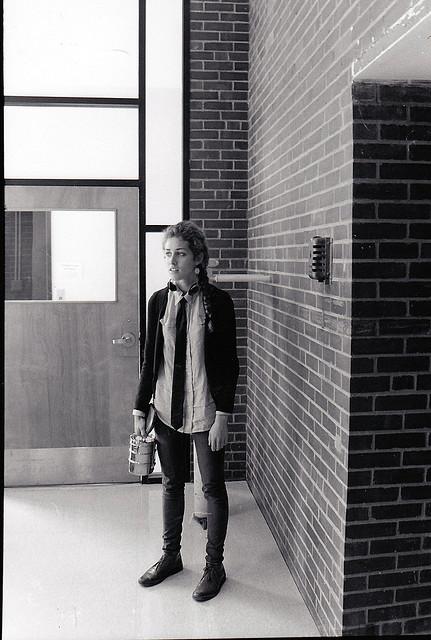What sort of boots are these?
Be succinct. Hiking. What is the wall made of?
Write a very short answer. Brick. What color are her shoes?
Quick response, please. Black. Is this woman inappropriately dressed?
Short answer required. No. Is this photo colored?
Concise answer only. No. What is the girl holding?
Short answer required. Can. 